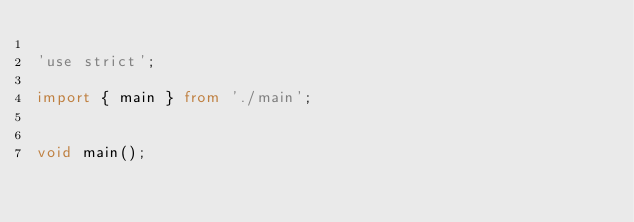Convert code to text. <code><loc_0><loc_0><loc_500><loc_500><_TypeScript_>
'use strict';

import { main } from './main';


void main();
</code> 